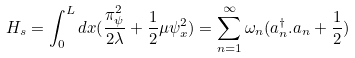Convert formula to latex. <formula><loc_0><loc_0><loc_500><loc_500>H _ { s } = \int _ { 0 } ^ { L } d x ( \frac { \pi _ { \psi } ^ { 2 } } { 2 \lambda } + \frac { 1 } { 2 } \mu \psi _ { x } ^ { 2 } ) = \sum _ { n = 1 } ^ { \infty } \omega _ { n } ( a _ { n } ^ { \dag } . a _ { n } + \frac { 1 } { 2 } )</formula> 